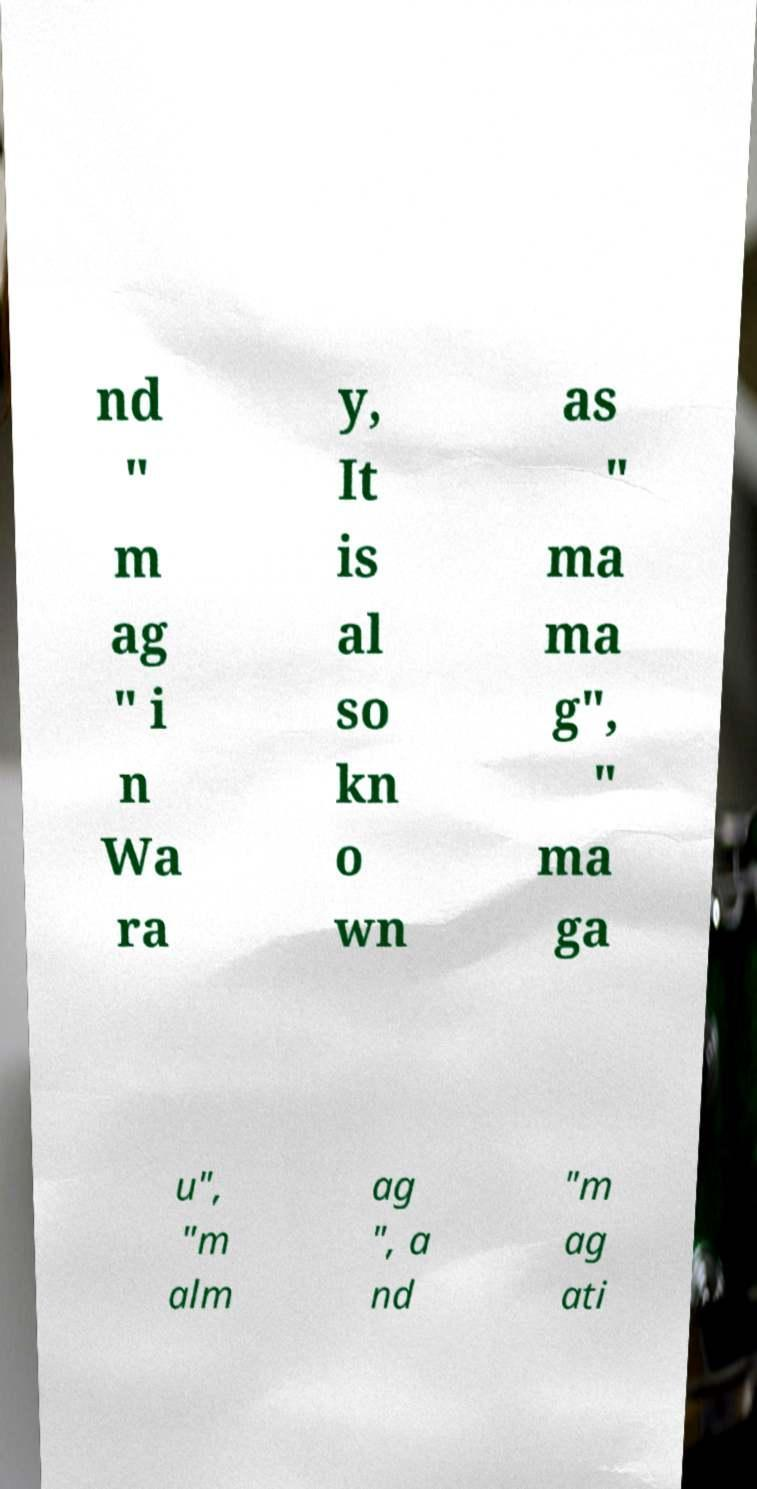There's text embedded in this image that I need extracted. Can you transcribe it verbatim? nd " m ag " i n Wa ra y, It is al so kn o wn as " ma ma g", " ma ga u", "m alm ag ", a nd "m ag ati 